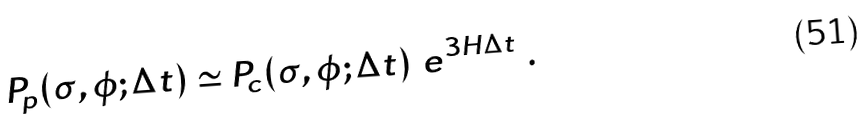<formula> <loc_0><loc_0><loc_500><loc_500>P _ { p } ( \sigma , \phi ; \Delta t ) \simeq P _ { c } ( \sigma , \phi ; \Delta t ) \ e ^ { 3 H \Delta t } \ .</formula> 